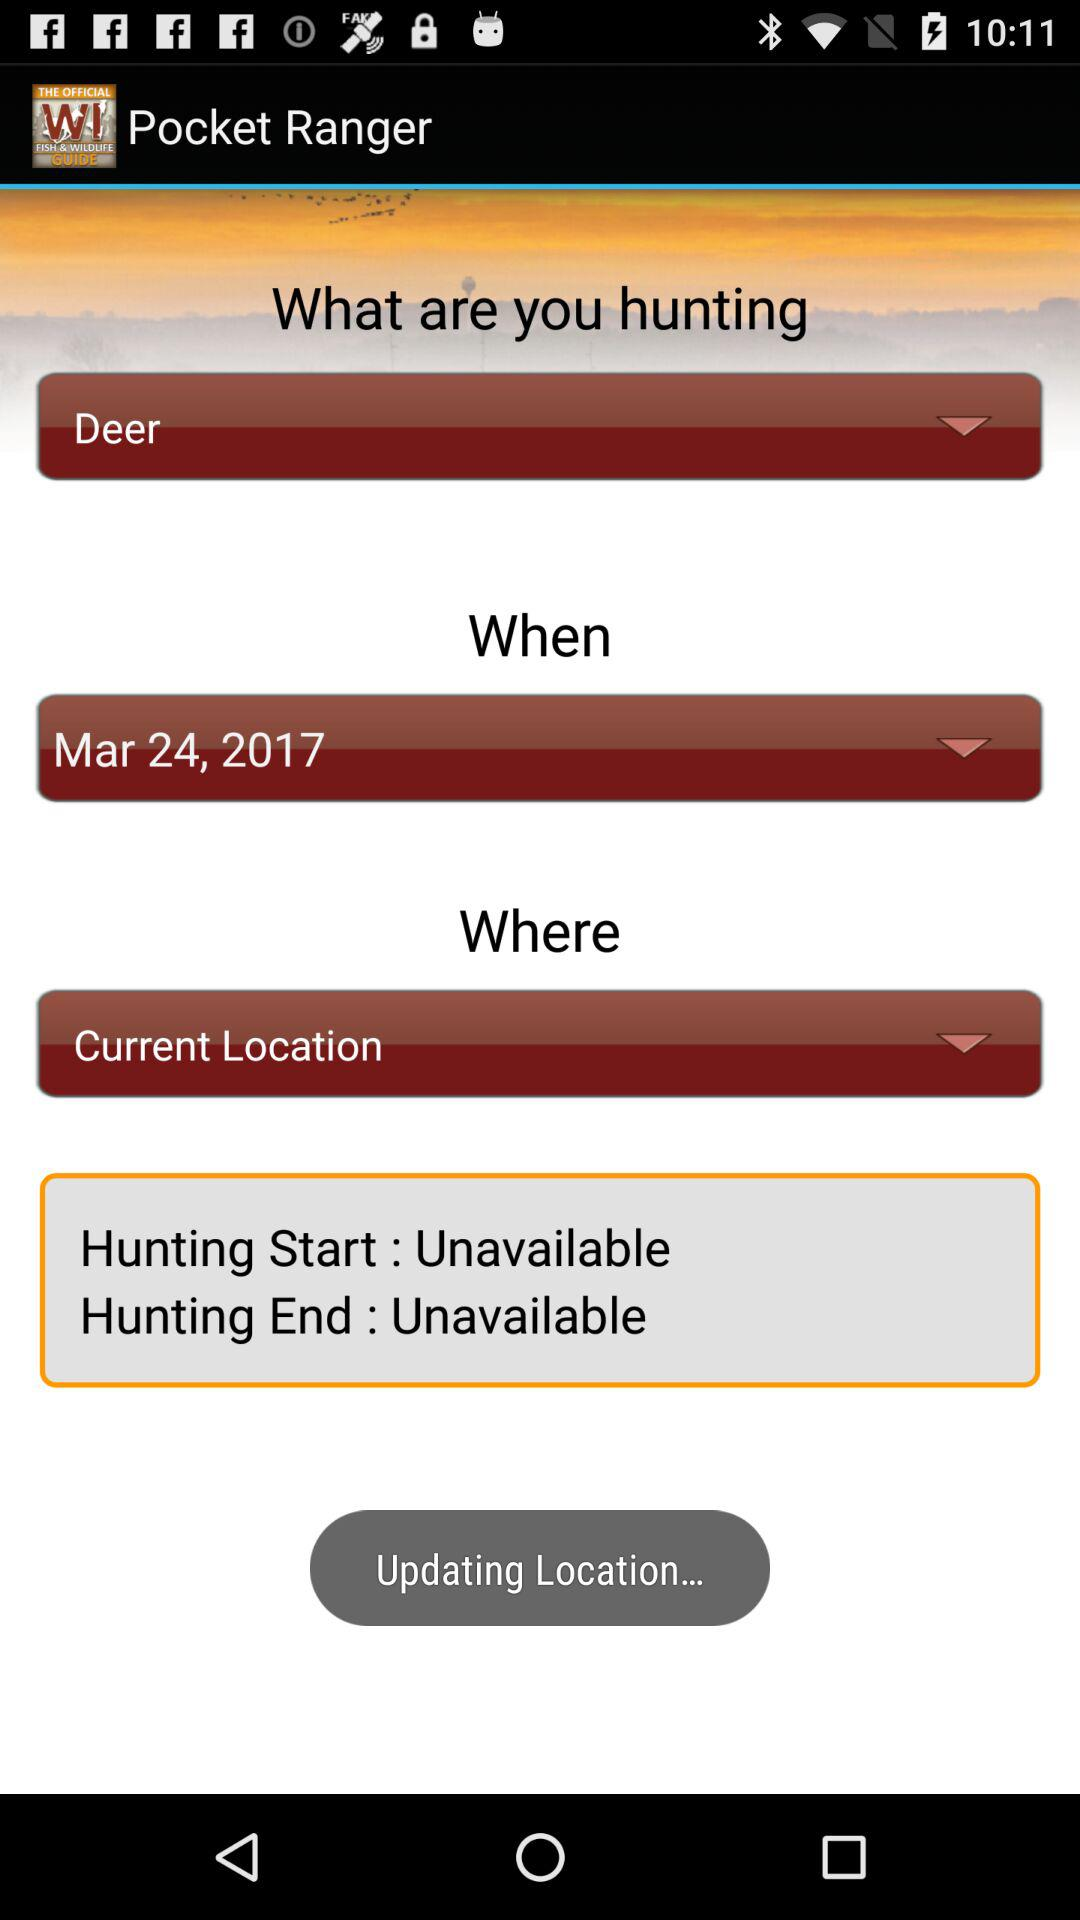When does deer hunting take place? Deer hunting takes place on 24th March, 2017. 